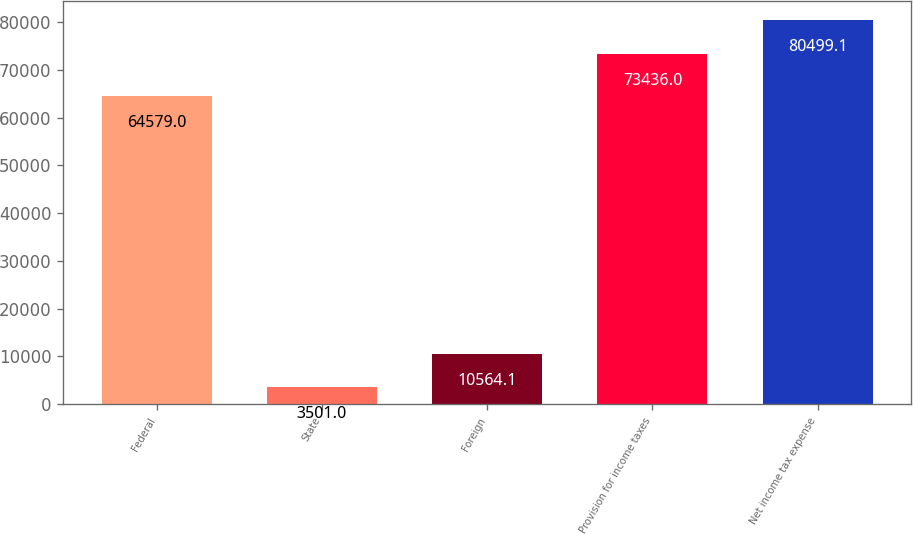Convert chart. <chart><loc_0><loc_0><loc_500><loc_500><bar_chart><fcel>Federal<fcel>State<fcel>Foreign<fcel>Provision for income taxes<fcel>Net income tax expense<nl><fcel>64579<fcel>3501<fcel>10564.1<fcel>73436<fcel>80499.1<nl></chart> 